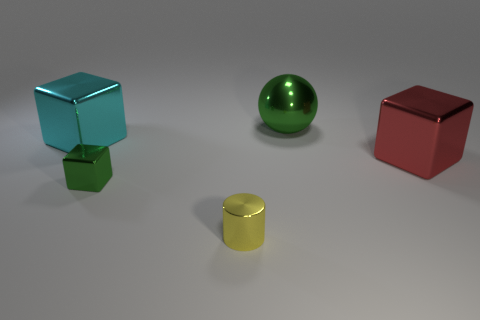There is a tiny object that is the same color as the big metallic sphere; what shape is it?
Your response must be concise. Cube. Is the number of large objects that are left of the big red block greater than the number of big cyan metallic things?
Give a very brief answer. Yes. Do the large metallic thing on the left side of the small green object and the red thing have the same shape?
Ensure brevity in your answer.  Yes. Is there anything else that has the same material as the big green sphere?
Your answer should be compact. Yes. What number of objects are blue rubber things or things behind the green cube?
Ensure brevity in your answer.  3. What is the size of the object that is behind the red metal cube and to the right of the tiny green thing?
Ensure brevity in your answer.  Large. Are there more small yellow objects on the left side of the small yellow metal cylinder than tiny green metallic objects that are left of the red object?
Keep it short and to the point. No. There is a cyan metallic object; is its shape the same as the object that is to the right of the big green metallic ball?
Provide a succinct answer. Yes. How many other objects are the same shape as the large red object?
Your answer should be very brief. 2. What is the color of the big metal object that is behind the red metallic object and in front of the ball?
Provide a short and direct response. Cyan. 